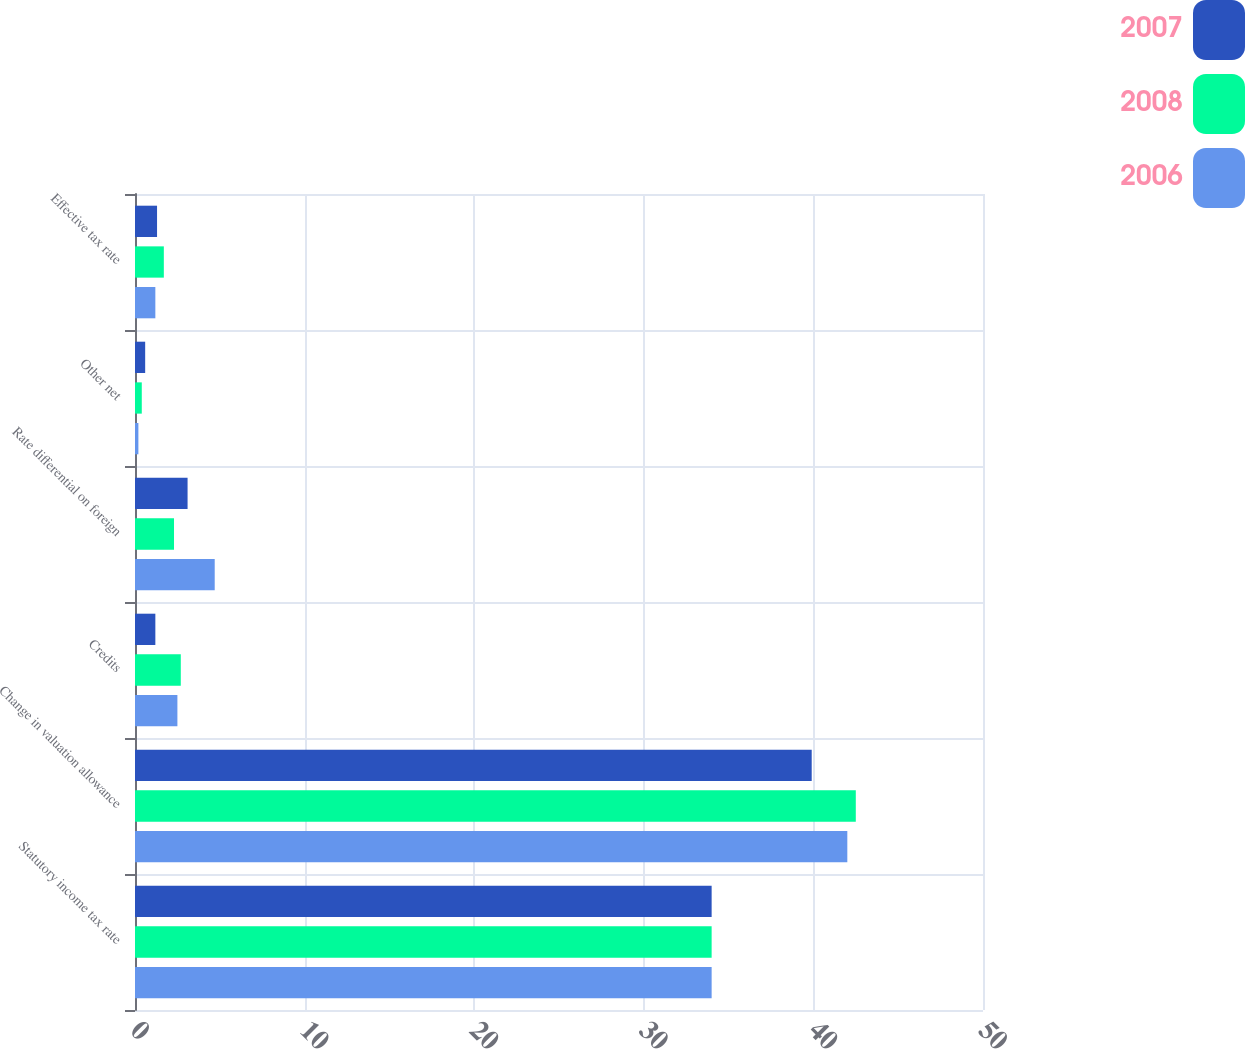Convert chart to OTSL. <chart><loc_0><loc_0><loc_500><loc_500><stacked_bar_chart><ecel><fcel>Statutory income tax rate<fcel>Change in valuation allowance<fcel>Credits<fcel>Rate differential on foreign<fcel>Other net<fcel>Effective tax rate<nl><fcel>2007<fcel>34<fcel>39.9<fcel>1.2<fcel>3.1<fcel>0.6<fcel>1.3<nl><fcel>2008<fcel>34<fcel>42.5<fcel>2.7<fcel>2.3<fcel>0.4<fcel>1.7<nl><fcel>2006<fcel>34<fcel>42<fcel>2.5<fcel>4.7<fcel>0.2<fcel>1.2<nl></chart> 